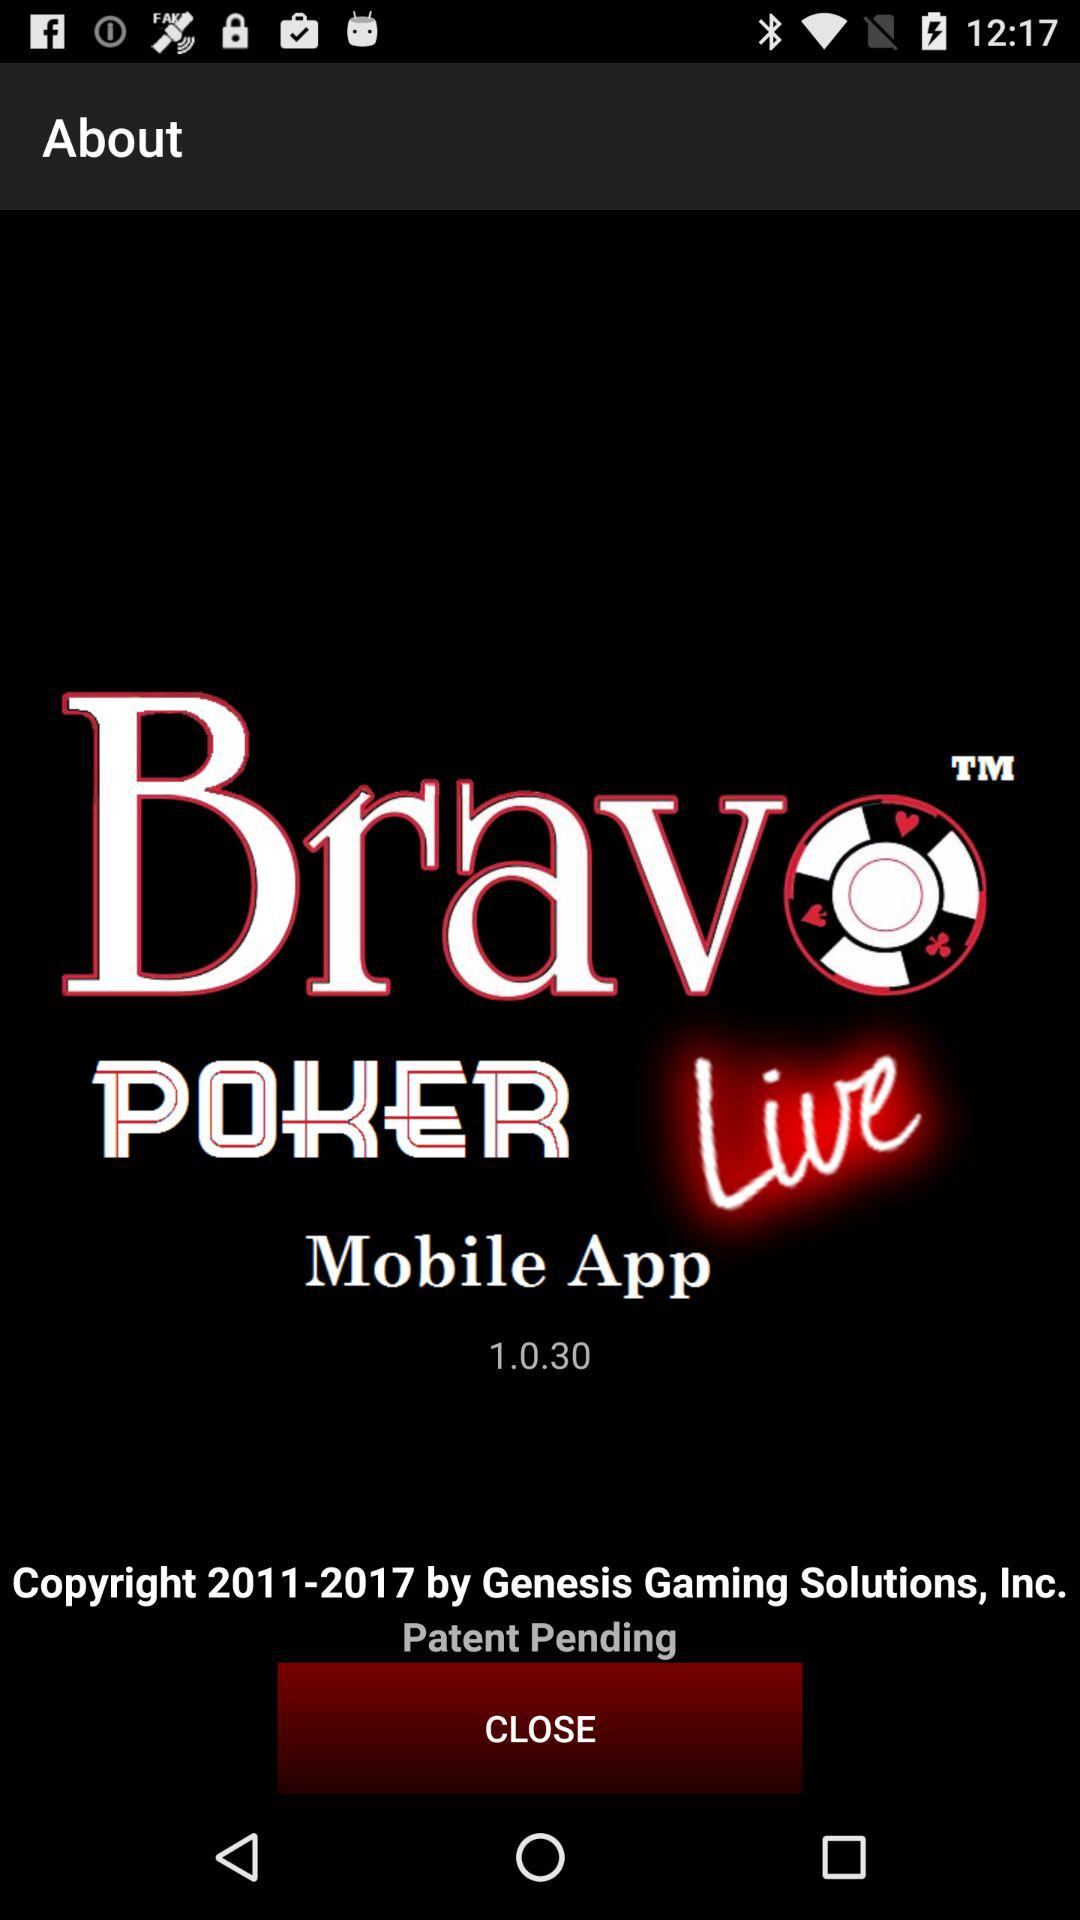What is the name of the application? The application name is "Bravo POKER Live". 